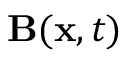<formula> <loc_0><loc_0><loc_500><loc_500>B ( x , t )</formula> 